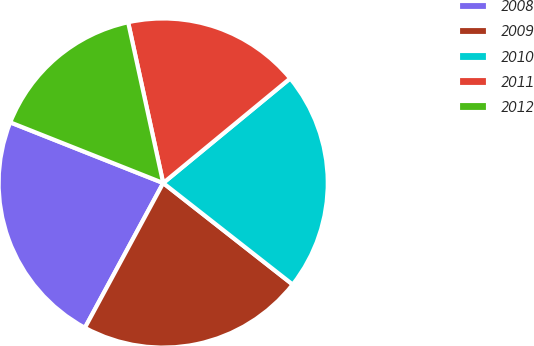Convert chart to OTSL. <chart><loc_0><loc_0><loc_500><loc_500><pie_chart><fcel>2008<fcel>2009<fcel>2010<fcel>2011<fcel>2012<nl><fcel>23.12%<fcel>22.31%<fcel>21.55%<fcel>17.45%<fcel>15.57%<nl></chart> 